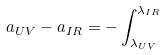<formula> <loc_0><loc_0><loc_500><loc_500>a _ { U V } - a _ { I R } = - \int _ { \lambda _ { U V } } ^ { \lambda _ { I R } }</formula> 